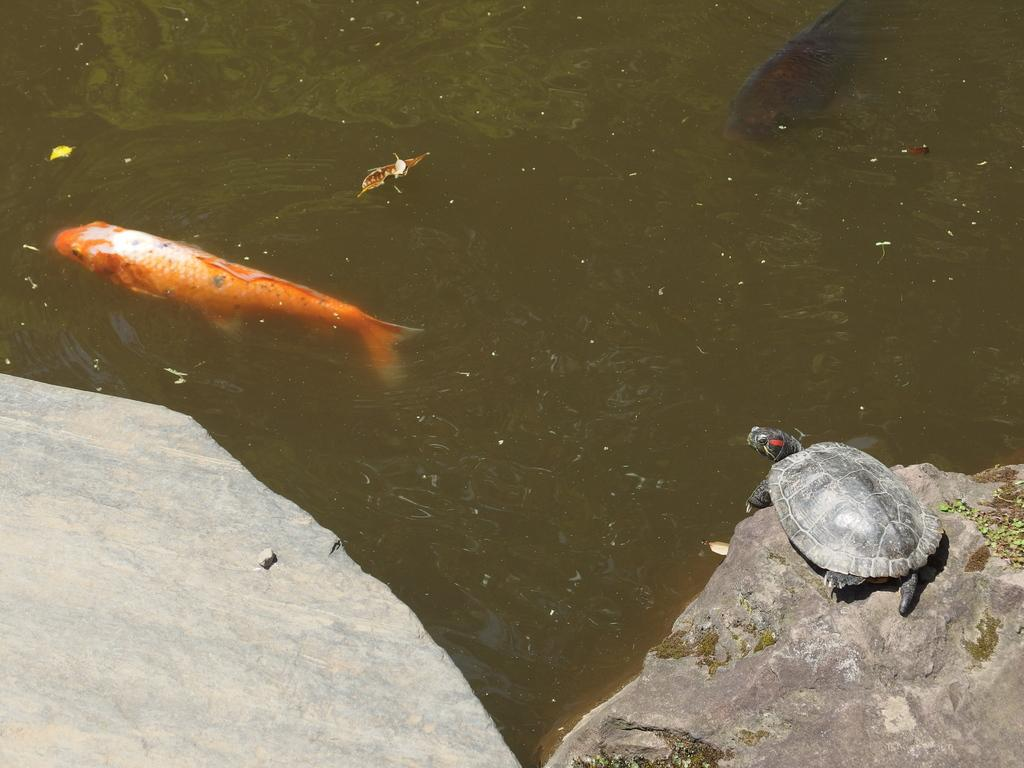What is the primary element in the image? There is water in the image. What type of animals can be seen in the water? There are fishes in the water. What other object or creature is present in the image? There is a tortoise on a rock on the right side of the image. What type of sleet can be seen falling in the image? There is no sleet present in the image; it features water, fishes, and a tortoise. How does the front of the tortoise compare to the front of the fishes in the image? There is no need to compare the front of the tortoise to the front of the fishes, as they are different animals and the image does not require such a comparison. 